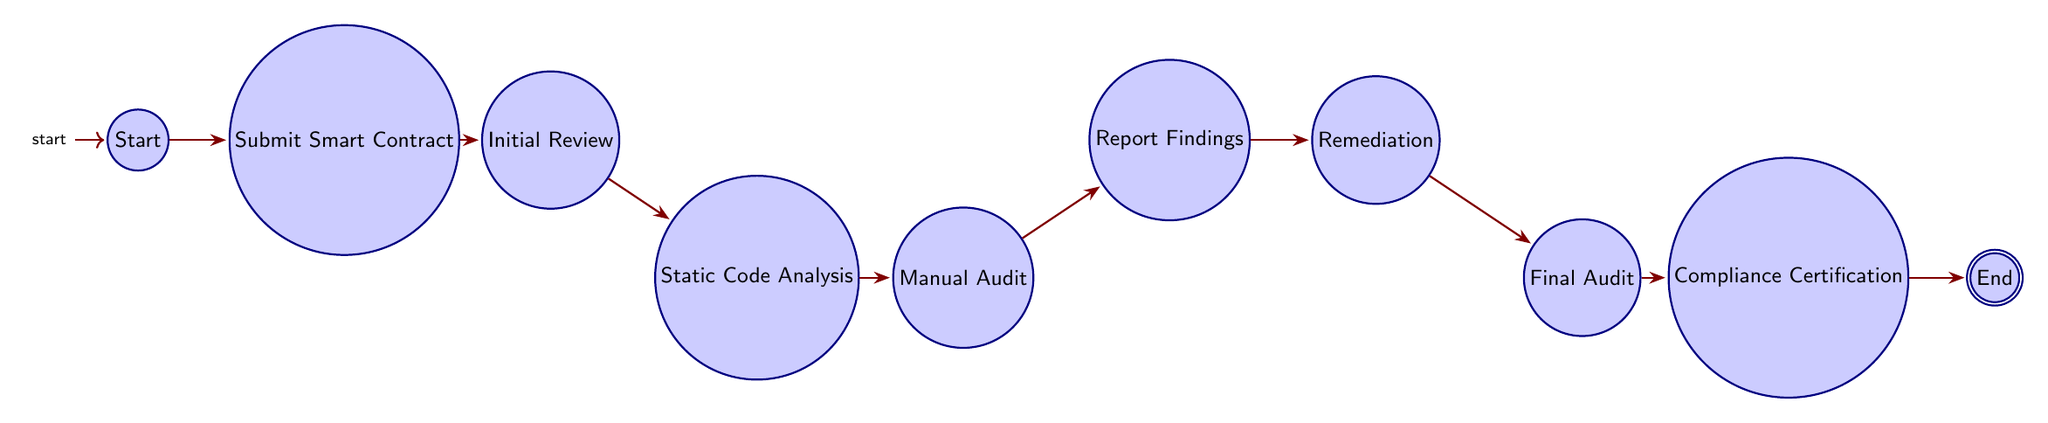What is the first step in the audit process? The first step is to submit the smart contract, which is indicated as the first node in the diagram. Following the starting point, the flow goes directly to the submission of the smart contract.
Answer: Submit Smart Contract How many nodes are there in the diagram? To find the number of nodes, count all unique states from "Start" to "End". There are a total of ten distinct nodes represented in the diagram.
Answer: 10 What follows after the initial review? After the initial review, the next action taken is static code analysis, which is positioned directly following the initial review in the flow.
Answer: Static Code Analysis Which node comes before compliance certification? The node that comes before compliance certification is the final audit, which directly precedes compliance certification in the sequence of processes outlined in the diagram.
Answer: Final Audit If issues are found during static analysis, what is the subsequent step? If issues are found during static analysis, the next step is to conduct a manual audit, which follows static analysis in the diagram flow after the review of the code.
Answer: Manual Audit What is the last step of the entire process? The last step of the entire process is the end node, which signifies the completion of the auditing and certification process.
Answer: End What are the last two stages before reaching the end of the process? The last two stages before reaching the end are compliance certification and the final audit, which are in sequence leading up to the diagram's termination at the end node.
Answer: Compliance Certification, Final Audit How many edges connect the nodes in the diagram? The number of edges can be determined by counting the connections between each node in the flow. There are nine directed edges connecting the ten nodes.
Answer: 9 What is the connection between reporting findings and remediation? Reporting findings leads directly to remediation, which is indicated by a single directed edge from the reporting findings node to the remediation node.
Answer: Remediation 